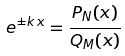<formula> <loc_0><loc_0><loc_500><loc_500>e ^ { \pm k \, x } = \frac { P _ { N } ( x ) } { Q _ { M } ( x ) }</formula> 